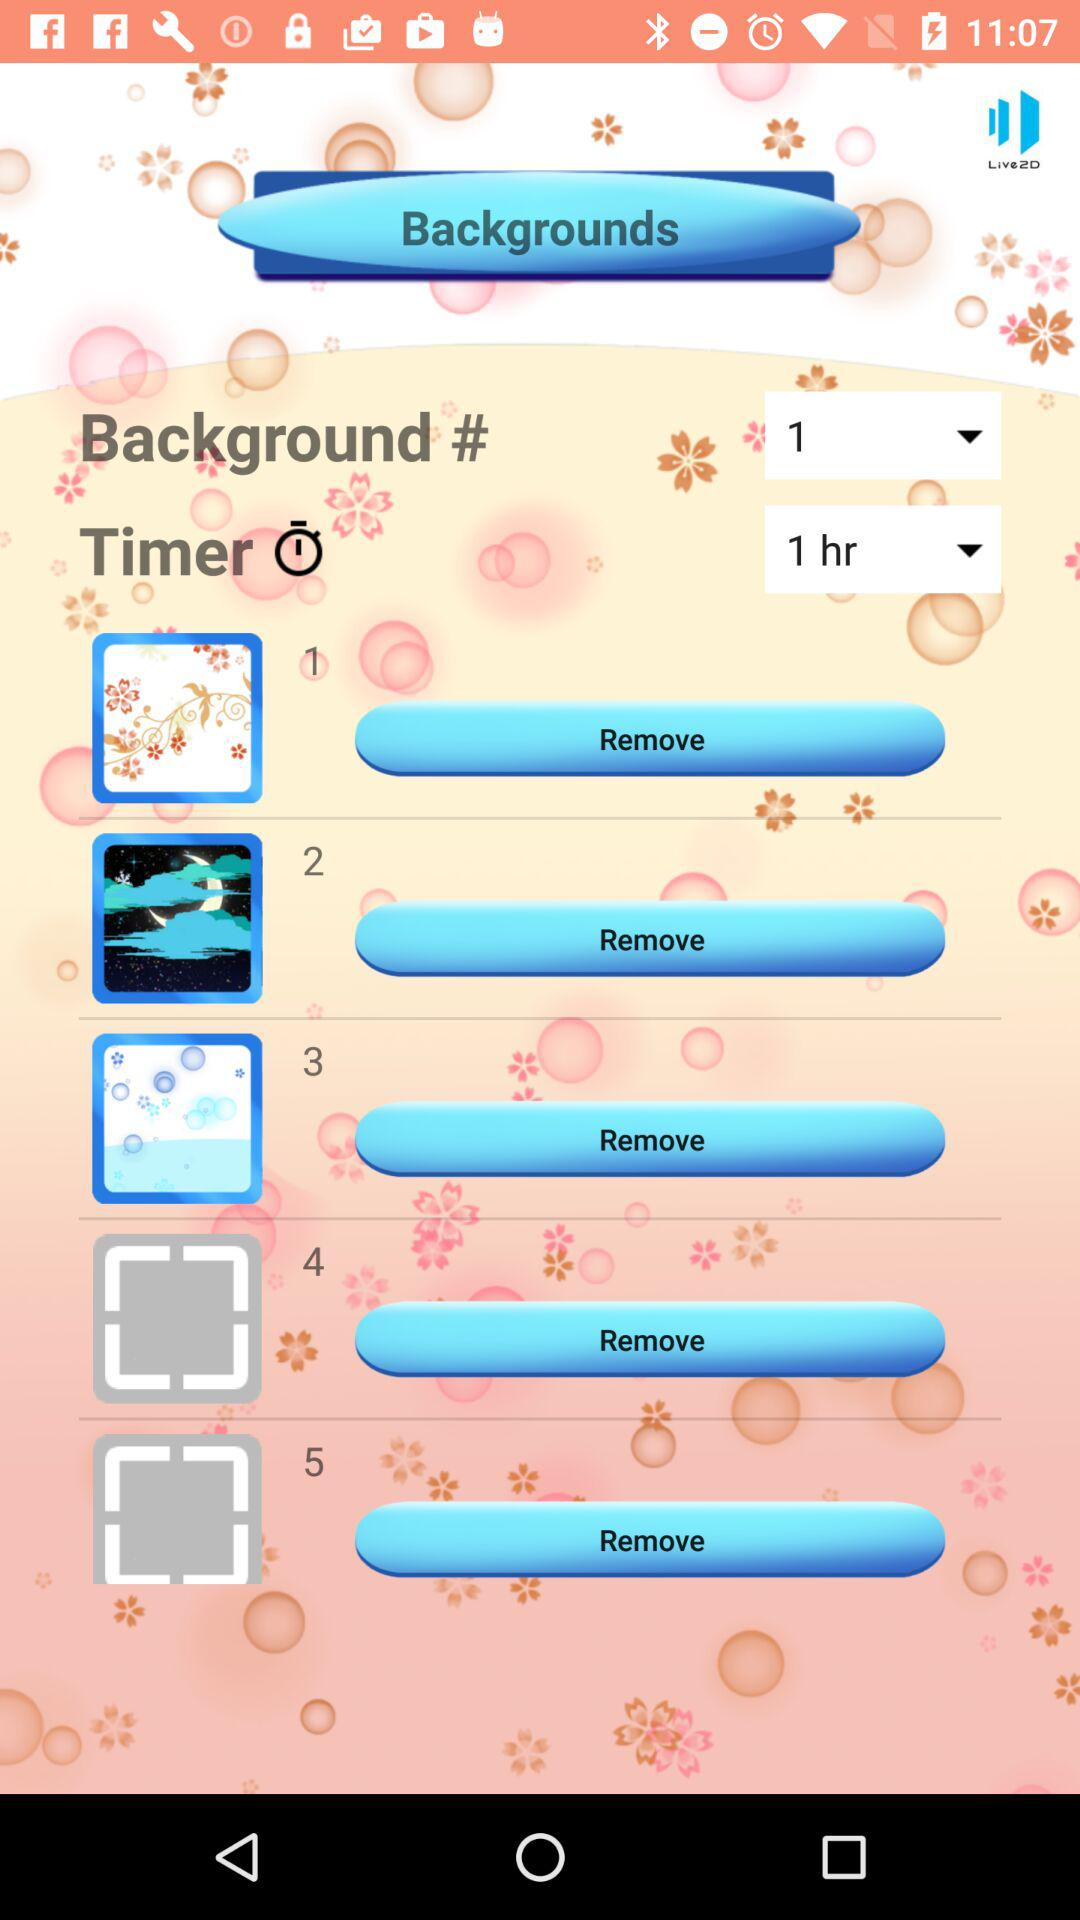When was background number 3 added?
When the provided information is insufficient, respond with <no answer>. <no answer> 